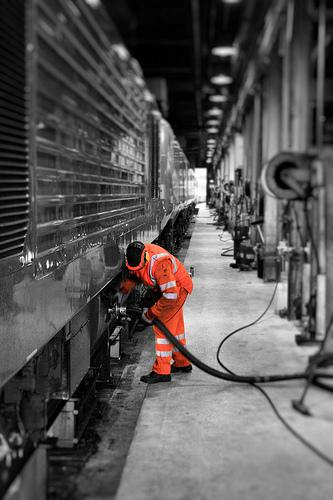Question: what color is his outfit?
Choices:
A. Bright yellow.
B. Bright orange.
C. Bright blue.
D. Bright red.
Answer with the letter. Answer: B Question: what is on his head?
Choices:
A. A fedora.
B. A knit cap.
C. A black hat.
D. A baseball cap.
Answer with the letter. Answer: C Question: what is he dressed in?
Choices:
A. Work clothes.
B. Casual clothes.
C. A uniform.
D. A tuxedo.
Answer with the letter. Answer: A Question: where was the photo taken?
Choices:
A. At the airport.
B. In a train yard.
C. At the bus station.
D. In the parking lot.
Answer with the letter. Answer: B Question: who is in the picture?
Choices:
A. A man.
B. A woman.
C. A girl.
D. A boy.
Answer with the letter. Answer: A Question: what is he holding?
Choices:
A. An axe.
B. A rake.
C. A chainsaw.
D. The handle of a hose.
Answer with the letter. Answer: D Question: what is he doing?
Choices:
A. Fixing the car.
B. Painting the airplane.
C. Overhauling the engine.
D. Servicing the train.
Answer with the letter. Answer: D 